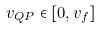<formula> <loc_0><loc_0><loc_500><loc_500>v _ { Q P } \in [ 0 , v _ { f } ]</formula> 